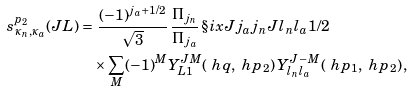<formula> <loc_0><loc_0><loc_500><loc_500>s _ { \kappa _ { n } , \kappa _ { a } } ^ { p _ { 2 } } ( J L ) = & \ \frac { ( - 1 ) ^ { j _ { a } + 1 / 2 } } { \sqrt { 3 } } \, \frac { \Pi _ { j _ { n } } } { \Pi _ { j _ { a } } } \, \S i x J { j _ { a } } { j _ { n } } { J } { l _ { n } } { l _ { a } } { 1 / 2 } \, \\ & \times \sum _ { M } ( - 1 ) ^ { M } Y _ { L 1 } ^ { J M } ( \ h q , \ h p _ { 2 } ) \, Y ^ { J \, - M } _ { l _ { n } l _ { a } } ( \ h p _ { 1 } , \ h p _ { 2 } ) \, ,</formula> 